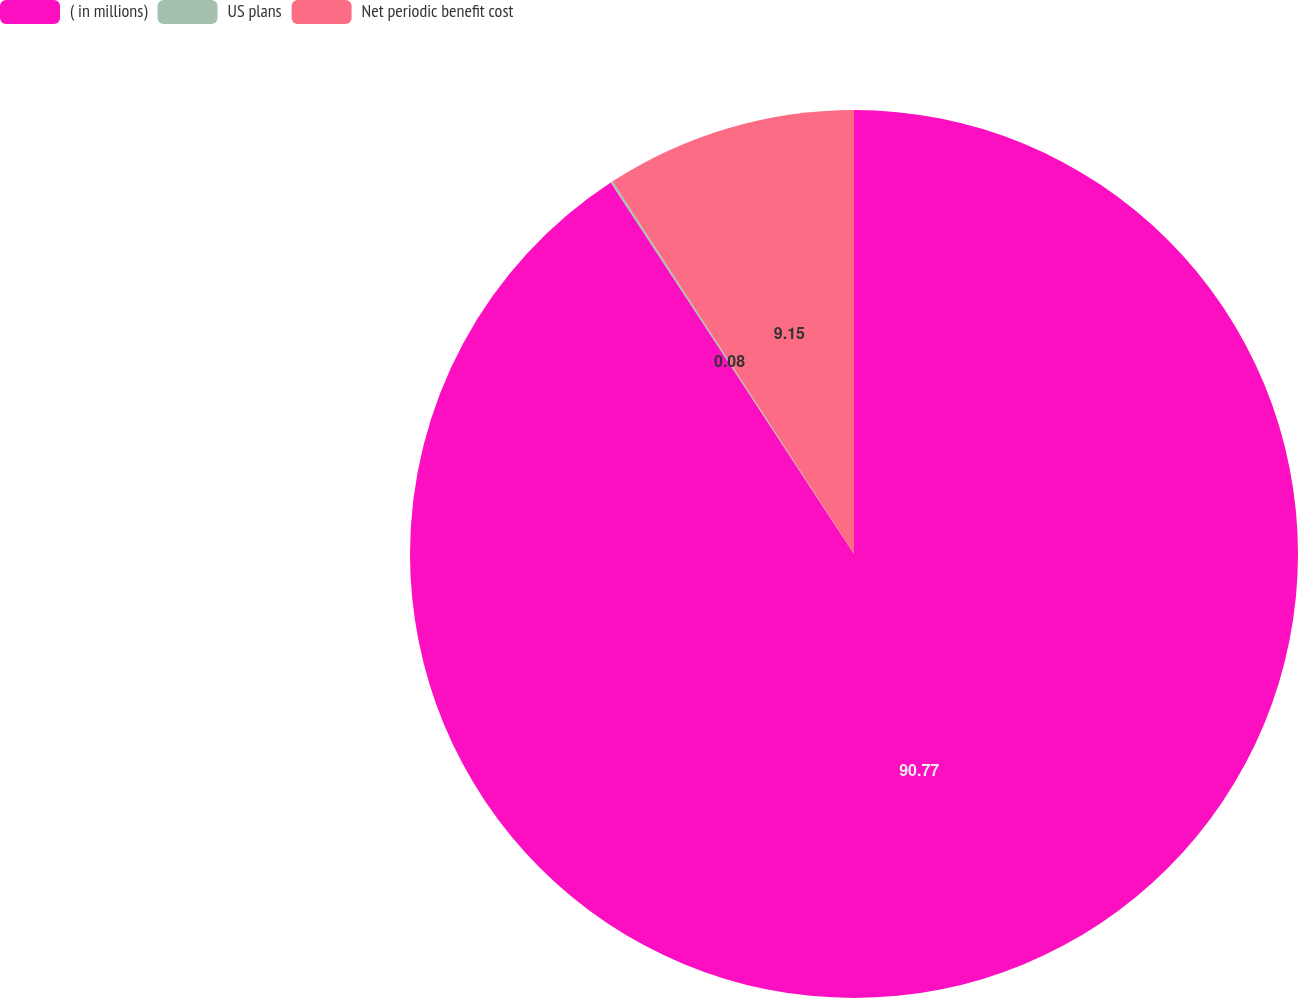Convert chart to OTSL. <chart><loc_0><loc_0><loc_500><loc_500><pie_chart><fcel>( in millions)<fcel>US plans<fcel>Net periodic benefit cost<nl><fcel>90.78%<fcel>0.08%<fcel>9.15%<nl></chart> 